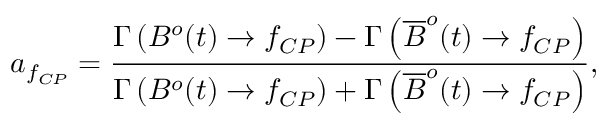Convert formula to latex. <formula><loc_0><loc_0><loc_500><loc_500>a _ { f _ { C P } } = { \frac { \Gamma \left ( B ^ { o } ( t ) \to f _ { C P } \right ) - \Gamma \left ( \overline { B } ^ { o } ( t ) \to f _ { C P } \right ) } { \Gamma \left ( B ^ { o } ( t ) \to f _ { C P } \right ) + \Gamma \left ( \overline { B } ^ { o } ( t ) \to f _ { C P } \right ) } } ,</formula> 